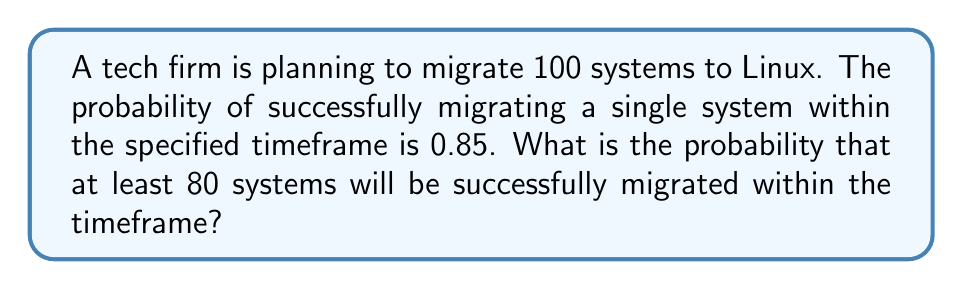Could you help me with this problem? To solve this problem, we need to use the binomial distribution:

1. Let X be the number of successfully migrated systems.
2. X follows a binomial distribution with n = 100 (total systems) and p = 0.85 (probability of success for each system).
3. We need to find P(X ≥ 80).

Using the complement rule:
P(X ≥ 80) = 1 - P(X < 80) = 1 - P(X ≤ 79)

The exact calculation using the binomial distribution would be:

$$1 - \sum_{k=0}^{79} \binom{100}{k} (0.85)^k (0.15)^{100-k}$$

However, for large n and np > 5, we can approximate the binomial distribution with a normal distribution:

4. μ = np = 100 * 0.85 = 85
5. σ² = np(1-p) = 100 * 0.85 * 0.15 = 12.75
6. σ = √12.75 ≈ 3.57

Using the continuity correction:
P(X ≥ 80) ≈ P(X > 79.5) in the normal approximation

7. Calculate the z-score:
   $$z = \frac{79.5 - 85}{3.57} ≈ -1.54$$

8. Look up the probability for z = -1.54 in a standard normal table or use a calculator:
   P(Z > -1.54) ≈ 0.9382

Therefore, the probability that at least 80 systems will be successfully migrated is approximately 0.9382 or 93.82%.
Answer: 0.9382 